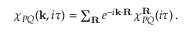<formula> <loc_0><loc_0><loc_500><loc_500>\begin{array} { r } { \chi _ { P Q } ( k , i \tau ) = \sum _ { R } e ^ { - i k \cdot R } \, \chi _ { P Q } ^ { R } ( i \tau ) \, . } \end{array}</formula> 